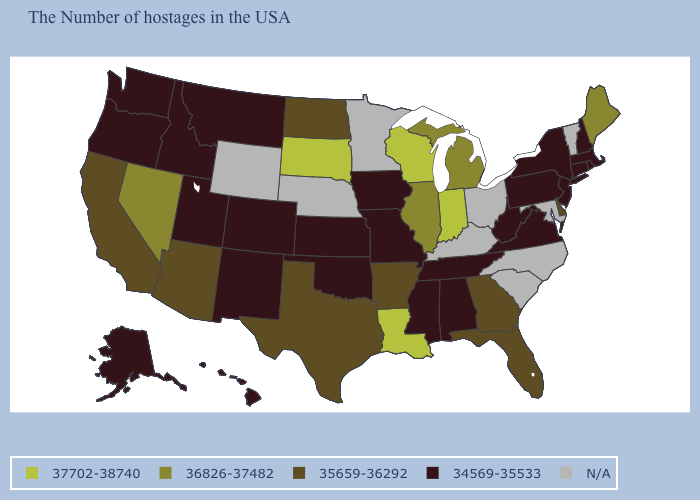What is the value of Wisconsin?
Quick response, please. 37702-38740. Among the states that border Oklahoma , which have the highest value?
Be succinct. Arkansas, Texas. Among the states that border Maryland , does Pennsylvania have the lowest value?
Keep it brief. Yes. What is the value of Montana?
Answer briefly. 34569-35533. Does Arizona have the lowest value in the West?
Short answer required. No. Which states have the lowest value in the USA?
Concise answer only. Massachusetts, Rhode Island, New Hampshire, Connecticut, New York, New Jersey, Pennsylvania, Virginia, West Virginia, Alabama, Tennessee, Mississippi, Missouri, Iowa, Kansas, Oklahoma, Colorado, New Mexico, Utah, Montana, Idaho, Washington, Oregon, Alaska, Hawaii. What is the value of South Carolina?
Keep it brief. N/A. Name the states that have a value in the range 37702-38740?
Keep it brief. Indiana, Wisconsin, Louisiana, South Dakota. Name the states that have a value in the range 35659-36292?
Keep it brief. Delaware, Florida, Georgia, Arkansas, Texas, North Dakota, Arizona, California. What is the value of Florida?
Concise answer only. 35659-36292. Among the states that border Indiana , which have the lowest value?
Keep it brief. Michigan, Illinois. Name the states that have a value in the range 35659-36292?
Write a very short answer. Delaware, Florida, Georgia, Arkansas, Texas, North Dakota, Arizona, California. Among the states that border Louisiana , does Mississippi have the lowest value?
Keep it brief. Yes. What is the value of Georgia?
Answer briefly. 35659-36292. 